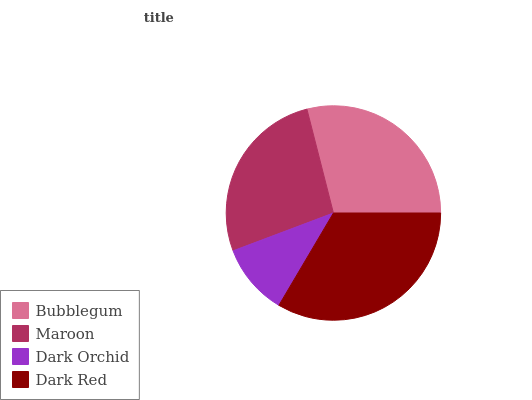Is Dark Orchid the minimum?
Answer yes or no. Yes. Is Dark Red the maximum?
Answer yes or no. Yes. Is Maroon the minimum?
Answer yes or no. No. Is Maroon the maximum?
Answer yes or no. No. Is Bubblegum greater than Maroon?
Answer yes or no. Yes. Is Maroon less than Bubblegum?
Answer yes or no. Yes. Is Maroon greater than Bubblegum?
Answer yes or no. No. Is Bubblegum less than Maroon?
Answer yes or no. No. Is Bubblegum the high median?
Answer yes or no. Yes. Is Maroon the low median?
Answer yes or no. Yes. Is Dark Red the high median?
Answer yes or no. No. Is Dark Orchid the low median?
Answer yes or no. No. 